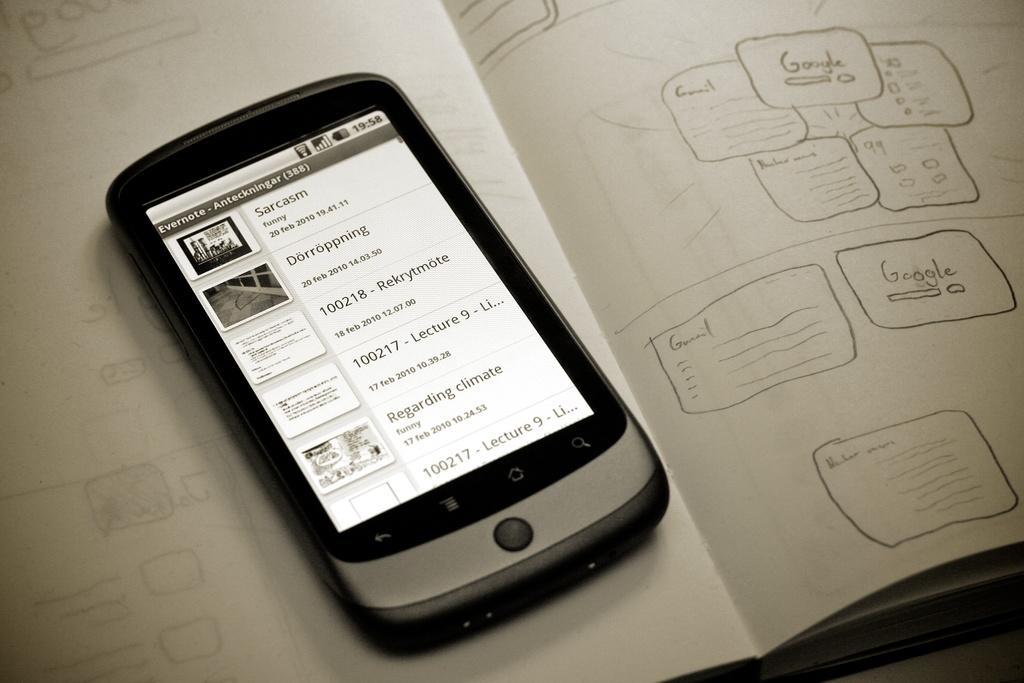<image>
Provide a brief description of the given image. a small black and silver phone with the word 'sarcasm' on the screen 